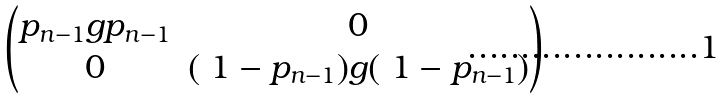<formula> <loc_0><loc_0><loc_500><loc_500>\begin{pmatrix} p _ { n - 1 } g p _ { n - 1 } & 0 \\ 0 & ( \ 1 - p _ { n - 1 } ) g ( \ 1 - p _ { n - 1 } ) \end{pmatrix}</formula> 